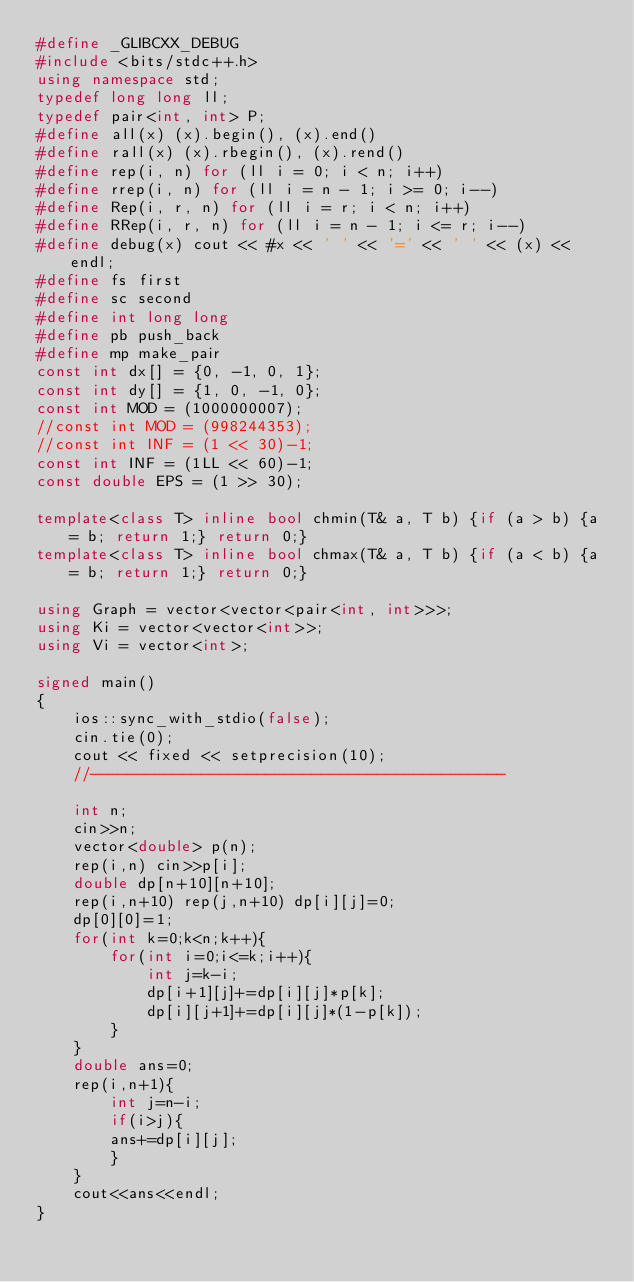<code> <loc_0><loc_0><loc_500><loc_500><_C++_>#define _GLIBCXX_DEBUG
#include <bits/stdc++.h>
using namespace std;
typedef long long ll;
typedef pair<int, int> P;
#define all(x) (x).begin(), (x).end()
#define rall(x) (x).rbegin(), (x).rend()
#define rep(i, n) for (ll i = 0; i < n; i++)
#define rrep(i, n) for (ll i = n - 1; i >= 0; i--)
#define Rep(i, r, n) for (ll i = r; i < n; i++)
#define RRep(i, r, n) for (ll i = n - 1; i <= r; i--)
#define debug(x) cout << #x << ' ' << '=' << ' ' << (x) << endl;
#define fs first
#define sc second
#define int long long
#define pb push_back
#define mp make_pair
const int dx[] = {0, -1, 0, 1};
const int dy[] = {1, 0, -1, 0};
const int MOD = (1000000007);
//const int MOD = (998244353);
//const int INF = (1 << 30)-1;
const int INF = (1LL << 60)-1;
const double EPS = (1 >> 30);

template<class T> inline bool chmin(T& a, T b) {if (a > b) {a = b; return 1;} return 0;}
template<class T> inline bool chmax(T& a, T b) {if (a < b) {a = b; return 1;} return 0;}

using Graph = vector<vector<pair<int, int>>>;
using Ki = vector<vector<int>>;
using Vi = vector<int>;

signed main()
{
    ios::sync_with_stdio(false);
    cin.tie(0);
    cout << fixed << setprecision(10);
    //---------------------------------------------
    
    int n;
    cin>>n;
    vector<double> p(n);
    rep(i,n) cin>>p[i];
    double dp[n+10][n+10];
    rep(i,n+10) rep(j,n+10) dp[i][j]=0;
    dp[0][0]=1;
    for(int k=0;k<n;k++){
        for(int i=0;i<=k;i++){
            int j=k-i;
            dp[i+1][j]+=dp[i][j]*p[k];
            dp[i][j+1]+=dp[i][j]*(1-p[k]);
        }
    }
    double ans=0;
    rep(i,n+1){
        int j=n-i;
        if(i>j){
        ans+=dp[i][j];
        }
    }
    cout<<ans<<endl;
}
</code> 